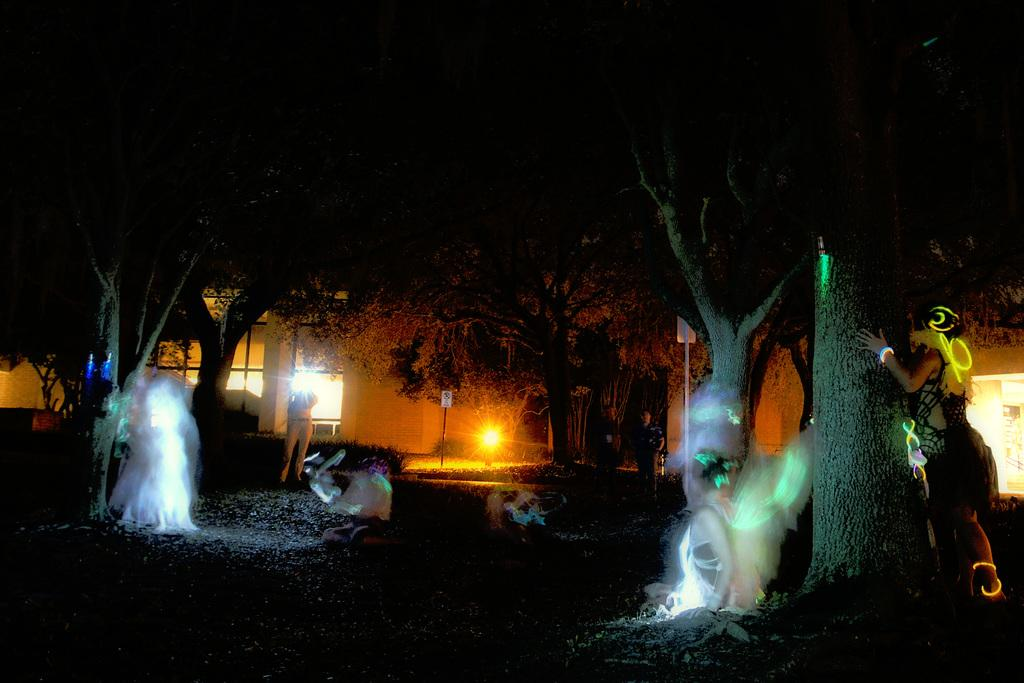What can be seen in the image? There are persons standing in the image, along with trees, a building, and a pole. Can you describe the persons in the image? The persons in the image are standing, but their specific actions or expressions cannot be determined from the provided facts. What type of structure is visible in the image? There is a building in the image. What else can be seen in the image besides the persons and the building? There are trees and a pole in the image. What type of plate is being used by the persons in the image? There is no plate present in the image; the persons are standing without any visible objects in their hands. Can you describe the facial expressions of the persons in the image? The provided facts do not mention any facial expressions of the persons in the image, so we cannot determine their expressions. 